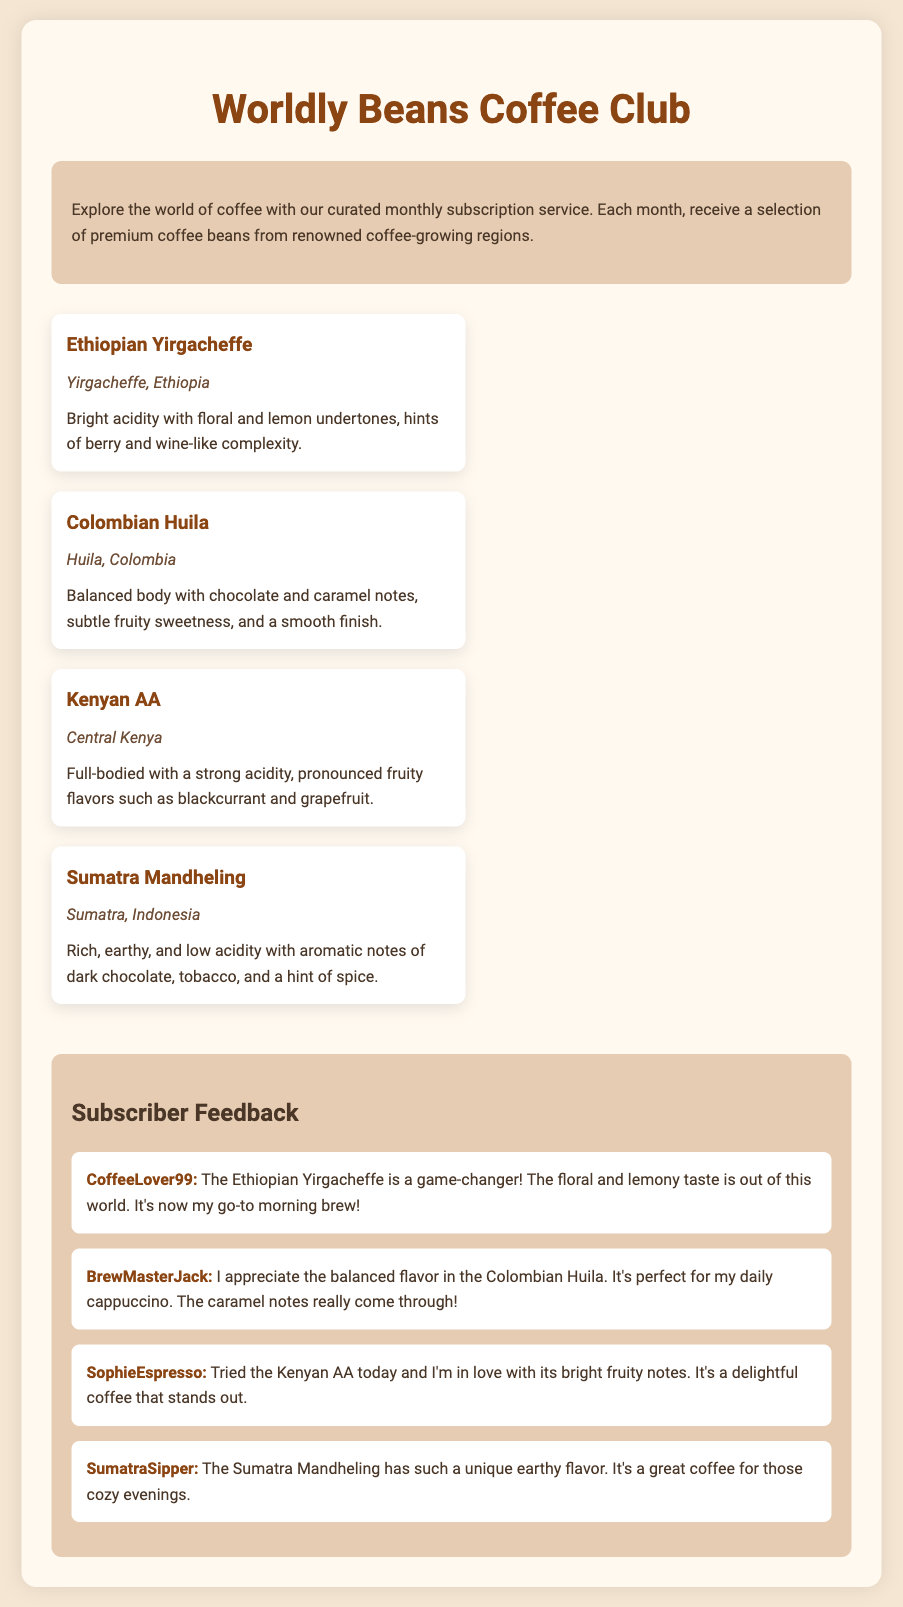What is the name of the coffee bean from Ethiopia? The name of the coffee bean from Ethiopia is Ethiopian Yirgacheffe.
Answer: Ethiopian Yirgacheffe What region is the Colombian Huila coffee from? The Colombian Huila coffee is sourced from the Huila region in Colombia.
Answer: Huila, Colombia What tasting notes are associated with the Kenyan AA coffee? The tasting notes for the Kenyan AA coffee include pronounced fruity flavors such as blackcurrant and grapefruit.
Answer: Blackcurrant and grapefruit Which coffee has the tasting notes of dark chocolate and tobacco? The coffee with tasting notes of dark chocolate and tobacco is the Sumatra Mandheling.
Answer: Sumatra Mandheling Who mentioned that Ethiopian Yirgacheffe is their go-to morning brew? The subscriber who mentioned that Ethiopian Yirgacheffe is their go-to morning brew is CoffeeLover99.
Answer: CoffeeLover99 Which coffee is appreciated for its balanced flavor in daily cappuccinos? The coffee appreciated for its balanced flavor in daily cappuccinos is Colombian Huila.
Answer: Colombian Huila What kind of flavor does the Sumatra Mandheling have? The flavor of the Sumatra Mandheling is described as unique and earthy.
Answer: Unique earthy flavor How many feedback items are presented in the document? The document presents four feedback items from subscribers.
Answer: Four What type of drink did BrewMasterJack associate with Colombian Huila? BrewMasterJack associated Colombian Huila with a cappuccino.
Answer: Cappuccino 